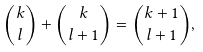<formula> <loc_0><loc_0><loc_500><loc_500>\binom { k } { l } + \binom { k } { l + 1 } = \binom { k + 1 } { l + 1 } ,</formula> 